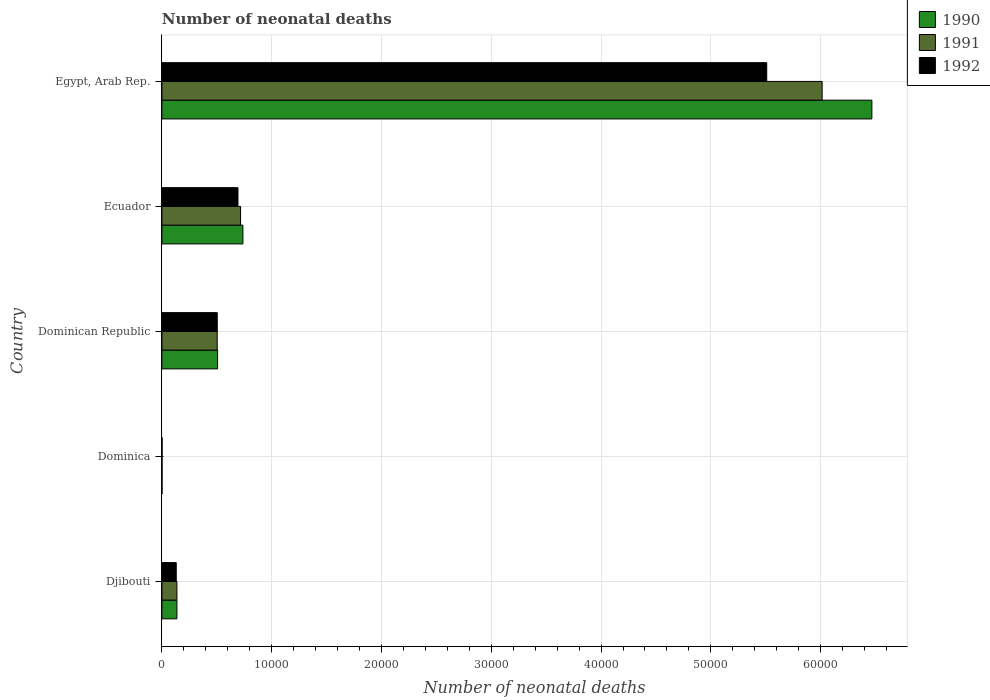How many different coloured bars are there?
Your answer should be very brief. 3. How many groups of bars are there?
Offer a very short reply. 5. How many bars are there on the 2nd tick from the top?
Your answer should be very brief. 3. What is the label of the 1st group of bars from the top?
Provide a succinct answer. Egypt, Arab Rep. In how many cases, is the number of bars for a given country not equal to the number of legend labels?
Give a very brief answer. 0. What is the number of neonatal deaths in in 1991 in Egypt, Arab Rep.?
Provide a short and direct response. 6.01e+04. Across all countries, what is the maximum number of neonatal deaths in in 1991?
Your answer should be very brief. 6.01e+04. Across all countries, what is the minimum number of neonatal deaths in in 1992?
Give a very brief answer. 15. In which country was the number of neonatal deaths in in 1992 maximum?
Your response must be concise. Egypt, Arab Rep. In which country was the number of neonatal deaths in in 1990 minimum?
Ensure brevity in your answer.  Dominica. What is the total number of neonatal deaths in in 1991 in the graph?
Offer a terse response. 7.37e+04. What is the difference between the number of neonatal deaths in in 1991 in Dominican Republic and that in Ecuador?
Your answer should be very brief. -2127. What is the difference between the number of neonatal deaths in in 1992 in Dominica and the number of neonatal deaths in in 1991 in Ecuador?
Make the answer very short. -7150. What is the average number of neonatal deaths in in 1991 per country?
Your answer should be very brief. 1.47e+04. What is the difference between the number of neonatal deaths in in 1990 and number of neonatal deaths in in 1991 in Egypt, Arab Rep.?
Your answer should be compact. 4529. What is the ratio of the number of neonatal deaths in in 1990 in Djibouti to that in Egypt, Arab Rep.?
Your response must be concise. 0.02. Is the difference between the number of neonatal deaths in in 1990 in Djibouti and Ecuador greater than the difference between the number of neonatal deaths in in 1991 in Djibouti and Ecuador?
Your response must be concise. No. What is the difference between the highest and the second highest number of neonatal deaths in in 1992?
Offer a terse response. 4.82e+04. What is the difference between the highest and the lowest number of neonatal deaths in in 1991?
Keep it short and to the point. 6.01e+04. Is the sum of the number of neonatal deaths in in 1991 in Dominican Republic and Ecuador greater than the maximum number of neonatal deaths in in 1992 across all countries?
Give a very brief answer. No. What does the 2nd bar from the top in Egypt, Arab Rep. represents?
Make the answer very short. 1991. How many bars are there?
Provide a succinct answer. 15. Are all the bars in the graph horizontal?
Provide a short and direct response. Yes. Are the values on the major ticks of X-axis written in scientific E-notation?
Provide a succinct answer. No. Does the graph contain grids?
Your response must be concise. Yes. Where does the legend appear in the graph?
Make the answer very short. Top right. How are the legend labels stacked?
Ensure brevity in your answer.  Vertical. What is the title of the graph?
Keep it short and to the point. Number of neonatal deaths. Does "1974" appear as one of the legend labels in the graph?
Make the answer very short. No. What is the label or title of the X-axis?
Provide a short and direct response. Number of neonatal deaths. What is the Number of neonatal deaths of 1990 in Djibouti?
Offer a terse response. 1368. What is the Number of neonatal deaths of 1991 in Djibouti?
Your answer should be very brief. 1367. What is the Number of neonatal deaths in 1992 in Djibouti?
Offer a very short reply. 1307. What is the Number of neonatal deaths in 1990 in Dominican Republic?
Keep it short and to the point. 5074. What is the Number of neonatal deaths of 1991 in Dominican Republic?
Provide a short and direct response. 5038. What is the Number of neonatal deaths of 1992 in Dominican Republic?
Your answer should be very brief. 5041. What is the Number of neonatal deaths of 1990 in Ecuador?
Offer a terse response. 7378. What is the Number of neonatal deaths of 1991 in Ecuador?
Offer a very short reply. 7165. What is the Number of neonatal deaths of 1992 in Ecuador?
Your response must be concise. 6929. What is the Number of neonatal deaths of 1990 in Egypt, Arab Rep.?
Provide a short and direct response. 6.47e+04. What is the Number of neonatal deaths in 1991 in Egypt, Arab Rep.?
Your answer should be compact. 6.01e+04. What is the Number of neonatal deaths in 1992 in Egypt, Arab Rep.?
Your answer should be compact. 5.51e+04. Across all countries, what is the maximum Number of neonatal deaths in 1990?
Offer a terse response. 6.47e+04. Across all countries, what is the maximum Number of neonatal deaths of 1991?
Your answer should be very brief. 6.01e+04. Across all countries, what is the maximum Number of neonatal deaths of 1992?
Keep it short and to the point. 5.51e+04. What is the total Number of neonatal deaths in 1990 in the graph?
Your answer should be very brief. 7.85e+04. What is the total Number of neonatal deaths in 1991 in the graph?
Keep it short and to the point. 7.37e+04. What is the total Number of neonatal deaths of 1992 in the graph?
Your response must be concise. 6.84e+04. What is the difference between the Number of neonatal deaths of 1990 in Djibouti and that in Dominica?
Your response must be concise. 1357. What is the difference between the Number of neonatal deaths in 1991 in Djibouti and that in Dominica?
Make the answer very short. 1354. What is the difference between the Number of neonatal deaths of 1992 in Djibouti and that in Dominica?
Give a very brief answer. 1292. What is the difference between the Number of neonatal deaths of 1990 in Djibouti and that in Dominican Republic?
Ensure brevity in your answer.  -3706. What is the difference between the Number of neonatal deaths of 1991 in Djibouti and that in Dominican Republic?
Provide a short and direct response. -3671. What is the difference between the Number of neonatal deaths of 1992 in Djibouti and that in Dominican Republic?
Give a very brief answer. -3734. What is the difference between the Number of neonatal deaths of 1990 in Djibouti and that in Ecuador?
Ensure brevity in your answer.  -6010. What is the difference between the Number of neonatal deaths of 1991 in Djibouti and that in Ecuador?
Offer a terse response. -5798. What is the difference between the Number of neonatal deaths in 1992 in Djibouti and that in Ecuador?
Ensure brevity in your answer.  -5622. What is the difference between the Number of neonatal deaths in 1990 in Djibouti and that in Egypt, Arab Rep.?
Offer a terse response. -6.33e+04. What is the difference between the Number of neonatal deaths in 1991 in Djibouti and that in Egypt, Arab Rep.?
Make the answer very short. -5.88e+04. What is the difference between the Number of neonatal deaths in 1992 in Djibouti and that in Egypt, Arab Rep.?
Your answer should be compact. -5.38e+04. What is the difference between the Number of neonatal deaths in 1990 in Dominica and that in Dominican Republic?
Ensure brevity in your answer.  -5063. What is the difference between the Number of neonatal deaths of 1991 in Dominica and that in Dominican Republic?
Your answer should be compact. -5025. What is the difference between the Number of neonatal deaths of 1992 in Dominica and that in Dominican Republic?
Provide a short and direct response. -5026. What is the difference between the Number of neonatal deaths of 1990 in Dominica and that in Ecuador?
Provide a succinct answer. -7367. What is the difference between the Number of neonatal deaths of 1991 in Dominica and that in Ecuador?
Give a very brief answer. -7152. What is the difference between the Number of neonatal deaths of 1992 in Dominica and that in Ecuador?
Your answer should be very brief. -6914. What is the difference between the Number of neonatal deaths in 1990 in Dominica and that in Egypt, Arab Rep.?
Offer a terse response. -6.47e+04. What is the difference between the Number of neonatal deaths in 1991 in Dominica and that in Egypt, Arab Rep.?
Offer a very short reply. -6.01e+04. What is the difference between the Number of neonatal deaths in 1992 in Dominica and that in Egypt, Arab Rep.?
Your answer should be compact. -5.51e+04. What is the difference between the Number of neonatal deaths of 1990 in Dominican Republic and that in Ecuador?
Ensure brevity in your answer.  -2304. What is the difference between the Number of neonatal deaths in 1991 in Dominican Republic and that in Ecuador?
Your response must be concise. -2127. What is the difference between the Number of neonatal deaths in 1992 in Dominican Republic and that in Ecuador?
Your response must be concise. -1888. What is the difference between the Number of neonatal deaths of 1990 in Dominican Republic and that in Egypt, Arab Rep.?
Offer a terse response. -5.96e+04. What is the difference between the Number of neonatal deaths of 1991 in Dominican Republic and that in Egypt, Arab Rep.?
Your answer should be very brief. -5.51e+04. What is the difference between the Number of neonatal deaths in 1992 in Dominican Republic and that in Egypt, Arab Rep.?
Your answer should be very brief. -5.00e+04. What is the difference between the Number of neonatal deaths of 1990 in Ecuador and that in Egypt, Arab Rep.?
Offer a very short reply. -5.73e+04. What is the difference between the Number of neonatal deaths of 1991 in Ecuador and that in Egypt, Arab Rep.?
Give a very brief answer. -5.30e+04. What is the difference between the Number of neonatal deaths of 1992 in Ecuador and that in Egypt, Arab Rep.?
Your response must be concise. -4.82e+04. What is the difference between the Number of neonatal deaths in 1990 in Djibouti and the Number of neonatal deaths in 1991 in Dominica?
Offer a very short reply. 1355. What is the difference between the Number of neonatal deaths in 1990 in Djibouti and the Number of neonatal deaths in 1992 in Dominica?
Ensure brevity in your answer.  1353. What is the difference between the Number of neonatal deaths in 1991 in Djibouti and the Number of neonatal deaths in 1992 in Dominica?
Your response must be concise. 1352. What is the difference between the Number of neonatal deaths in 1990 in Djibouti and the Number of neonatal deaths in 1991 in Dominican Republic?
Provide a succinct answer. -3670. What is the difference between the Number of neonatal deaths in 1990 in Djibouti and the Number of neonatal deaths in 1992 in Dominican Republic?
Give a very brief answer. -3673. What is the difference between the Number of neonatal deaths of 1991 in Djibouti and the Number of neonatal deaths of 1992 in Dominican Republic?
Offer a terse response. -3674. What is the difference between the Number of neonatal deaths in 1990 in Djibouti and the Number of neonatal deaths in 1991 in Ecuador?
Give a very brief answer. -5797. What is the difference between the Number of neonatal deaths in 1990 in Djibouti and the Number of neonatal deaths in 1992 in Ecuador?
Offer a terse response. -5561. What is the difference between the Number of neonatal deaths in 1991 in Djibouti and the Number of neonatal deaths in 1992 in Ecuador?
Your answer should be compact. -5562. What is the difference between the Number of neonatal deaths of 1990 in Djibouti and the Number of neonatal deaths of 1991 in Egypt, Arab Rep.?
Keep it short and to the point. -5.88e+04. What is the difference between the Number of neonatal deaths in 1990 in Djibouti and the Number of neonatal deaths in 1992 in Egypt, Arab Rep.?
Ensure brevity in your answer.  -5.37e+04. What is the difference between the Number of neonatal deaths of 1991 in Djibouti and the Number of neonatal deaths of 1992 in Egypt, Arab Rep.?
Keep it short and to the point. -5.37e+04. What is the difference between the Number of neonatal deaths of 1990 in Dominica and the Number of neonatal deaths of 1991 in Dominican Republic?
Your response must be concise. -5027. What is the difference between the Number of neonatal deaths in 1990 in Dominica and the Number of neonatal deaths in 1992 in Dominican Republic?
Your answer should be compact. -5030. What is the difference between the Number of neonatal deaths of 1991 in Dominica and the Number of neonatal deaths of 1992 in Dominican Republic?
Offer a very short reply. -5028. What is the difference between the Number of neonatal deaths of 1990 in Dominica and the Number of neonatal deaths of 1991 in Ecuador?
Your response must be concise. -7154. What is the difference between the Number of neonatal deaths of 1990 in Dominica and the Number of neonatal deaths of 1992 in Ecuador?
Provide a succinct answer. -6918. What is the difference between the Number of neonatal deaths of 1991 in Dominica and the Number of neonatal deaths of 1992 in Ecuador?
Give a very brief answer. -6916. What is the difference between the Number of neonatal deaths of 1990 in Dominica and the Number of neonatal deaths of 1991 in Egypt, Arab Rep.?
Your answer should be compact. -6.01e+04. What is the difference between the Number of neonatal deaths of 1990 in Dominica and the Number of neonatal deaths of 1992 in Egypt, Arab Rep.?
Keep it short and to the point. -5.51e+04. What is the difference between the Number of neonatal deaths in 1991 in Dominica and the Number of neonatal deaths in 1992 in Egypt, Arab Rep.?
Give a very brief answer. -5.51e+04. What is the difference between the Number of neonatal deaths in 1990 in Dominican Republic and the Number of neonatal deaths in 1991 in Ecuador?
Your answer should be very brief. -2091. What is the difference between the Number of neonatal deaths of 1990 in Dominican Republic and the Number of neonatal deaths of 1992 in Ecuador?
Provide a short and direct response. -1855. What is the difference between the Number of neonatal deaths of 1991 in Dominican Republic and the Number of neonatal deaths of 1992 in Ecuador?
Give a very brief answer. -1891. What is the difference between the Number of neonatal deaths in 1990 in Dominican Republic and the Number of neonatal deaths in 1991 in Egypt, Arab Rep.?
Make the answer very short. -5.51e+04. What is the difference between the Number of neonatal deaths in 1990 in Dominican Republic and the Number of neonatal deaths in 1992 in Egypt, Arab Rep.?
Ensure brevity in your answer.  -5.00e+04. What is the difference between the Number of neonatal deaths of 1991 in Dominican Republic and the Number of neonatal deaths of 1992 in Egypt, Arab Rep.?
Ensure brevity in your answer.  -5.00e+04. What is the difference between the Number of neonatal deaths in 1990 in Ecuador and the Number of neonatal deaths in 1991 in Egypt, Arab Rep.?
Ensure brevity in your answer.  -5.28e+04. What is the difference between the Number of neonatal deaths of 1990 in Ecuador and the Number of neonatal deaths of 1992 in Egypt, Arab Rep.?
Your answer should be very brief. -4.77e+04. What is the difference between the Number of neonatal deaths of 1991 in Ecuador and the Number of neonatal deaths of 1992 in Egypt, Arab Rep.?
Offer a terse response. -4.79e+04. What is the average Number of neonatal deaths of 1990 per country?
Your answer should be very brief. 1.57e+04. What is the average Number of neonatal deaths in 1991 per country?
Offer a very short reply. 1.47e+04. What is the average Number of neonatal deaths in 1992 per country?
Provide a short and direct response. 1.37e+04. What is the difference between the Number of neonatal deaths of 1991 and Number of neonatal deaths of 1992 in Djibouti?
Give a very brief answer. 60. What is the difference between the Number of neonatal deaths of 1990 and Number of neonatal deaths of 1991 in Dominica?
Your answer should be compact. -2. What is the difference between the Number of neonatal deaths in 1990 and Number of neonatal deaths in 1992 in Dominican Republic?
Provide a succinct answer. 33. What is the difference between the Number of neonatal deaths of 1991 and Number of neonatal deaths of 1992 in Dominican Republic?
Offer a terse response. -3. What is the difference between the Number of neonatal deaths in 1990 and Number of neonatal deaths in 1991 in Ecuador?
Provide a short and direct response. 213. What is the difference between the Number of neonatal deaths in 1990 and Number of neonatal deaths in 1992 in Ecuador?
Ensure brevity in your answer.  449. What is the difference between the Number of neonatal deaths in 1991 and Number of neonatal deaths in 1992 in Ecuador?
Your answer should be compact. 236. What is the difference between the Number of neonatal deaths in 1990 and Number of neonatal deaths in 1991 in Egypt, Arab Rep.?
Ensure brevity in your answer.  4529. What is the difference between the Number of neonatal deaths of 1990 and Number of neonatal deaths of 1992 in Egypt, Arab Rep.?
Your answer should be compact. 9576. What is the difference between the Number of neonatal deaths of 1991 and Number of neonatal deaths of 1992 in Egypt, Arab Rep.?
Provide a short and direct response. 5047. What is the ratio of the Number of neonatal deaths of 1990 in Djibouti to that in Dominica?
Provide a short and direct response. 124.36. What is the ratio of the Number of neonatal deaths of 1991 in Djibouti to that in Dominica?
Offer a very short reply. 105.15. What is the ratio of the Number of neonatal deaths of 1992 in Djibouti to that in Dominica?
Your answer should be compact. 87.13. What is the ratio of the Number of neonatal deaths in 1990 in Djibouti to that in Dominican Republic?
Provide a succinct answer. 0.27. What is the ratio of the Number of neonatal deaths in 1991 in Djibouti to that in Dominican Republic?
Make the answer very short. 0.27. What is the ratio of the Number of neonatal deaths of 1992 in Djibouti to that in Dominican Republic?
Give a very brief answer. 0.26. What is the ratio of the Number of neonatal deaths in 1990 in Djibouti to that in Ecuador?
Your answer should be compact. 0.19. What is the ratio of the Number of neonatal deaths in 1991 in Djibouti to that in Ecuador?
Your response must be concise. 0.19. What is the ratio of the Number of neonatal deaths in 1992 in Djibouti to that in Ecuador?
Offer a terse response. 0.19. What is the ratio of the Number of neonatal deaths of 1990 in Djibouti to that in Egypt, Arab Rep.?
Provide a short and direct response. 0.02. What is the ratio of the Number of neonatal deaths of 1991 in Djibouti to that in Egypt, Arab Rep.?
Your response must be concise. 0.02. What is the ratio of the Number of neonatal deaths of 1992 in Djibouti to that in Egypt, Arab Rep.?
Your response must be concise. 0.02. What is the ratio of the Number of neonatal deaths in 1990 in Dominica to that in Dominican Republic?
Give a very brief answer. 0. What is the ratio of the Number of neonatal deaths in 1991 in Dominica to that in Dominican Republic?
Keep it short and to the point. 0. What is the ratio of the Number of neonatal deaths of 1992 in Dominica to that in Dominican Republic?
Keep it short and to the point. 0. What is the ratio of the Number of neonatal deaths of 1990 in Dominica to that in Ecuador?
Your answer should be compact. 0. What is the ratio of the Number of neonatal deaths of 1991 in Dominica to that in Ecuador?
Ensure brevity in your answer.  0. What is the ratio of the Number of neonatal deaths of 1992 in Dominica to that in Ecuador?
Your answer should be very brief. 0. What is the ratio of the Number of neonatal deaths in 1990 in Dominica to that in Egypt, Arab Rep.?
Your response must be concise. 0. What is the ratio of the Number of neonatal deaths in 1991 in Dominica to that in Egypt, Arab Rep.?
Provide a succinct answer. 0. What is the ratio of the Number of neonatal deaths of 1992 in Dominica to that in Egypt, Arab Rep.?
Provide a short and direct response. 0. What is the ratio of the Number of neonatal deaths of 1990 in Dominican Republic to that in Ecuador?
Give a very brief answer. 0.69. What is the ratio of the Number of neonatal deaths in 1991 in Dominican Republic to that in Ecuador?
Provide a succinct answer. 0.7. What is the ratio of the Number of neonatal deaths of 1992 in Dominican Republic to that in Ecuador?
Ensure brevity in your answer.  0.73. What is the ratio of the Number of neonatal deaths in 1990 in Dominican Republic to that in Egypt, Arab Rep.?
Ensure brevity in your answer.  0.08. What is the ratio of the Number of neonatal deaths of 1991 in Dominican Republic to that in Egypt, Arab Rep.?
Give a very brief answer. 0.08. What is the ratio of the Number of neonatal deaths of 1992 in Dominican Republic to that in Egypt, Arab Rep.?
Ensure brevity in your answer.  0.09. What is the ratio of the Number of neonatal deaths in 1990 in Ecuador to that in Egypt, Arab Rep.?
Provide a succinct answer. 0.11. What is the ratio of the Number of neonatal deaths of 1991 in Ecuador to that in Egypt, Arab Rep.?
Make the answer very short. 0.12. What is the ratio of the Number of neonatal deaths in 1992 in Ecuador to that in Egypt, Arab Rep.?
Offer a terse response. 0.13. What is the difference between the highest and the second highest Number of neonatal deaths of 1990?
Offer a very short reply. 5.73e+04. What is the difference between the highest and the second highest Number of neonatal deaths in 1991?
Your answer should be very brief. 5.30e+04. What is the difference between the highest and the second highest Number of neonatal deaths in 1992?
Ensure brevity in your answer.  4.82e+04. What is the difference between the highest and the lowest Number of neonatal deaths of 1990?
Ensure brevity in your answer.  6.47e+04. What is the difference between the highest and the lowest Number of neonatal deaths in 1991?
Your response must be concise. 6.01e+04. What is the difference between the highest and the lowest Number of neonatal deaths of 1992?
Make the answer very short. 5.51e+04. 